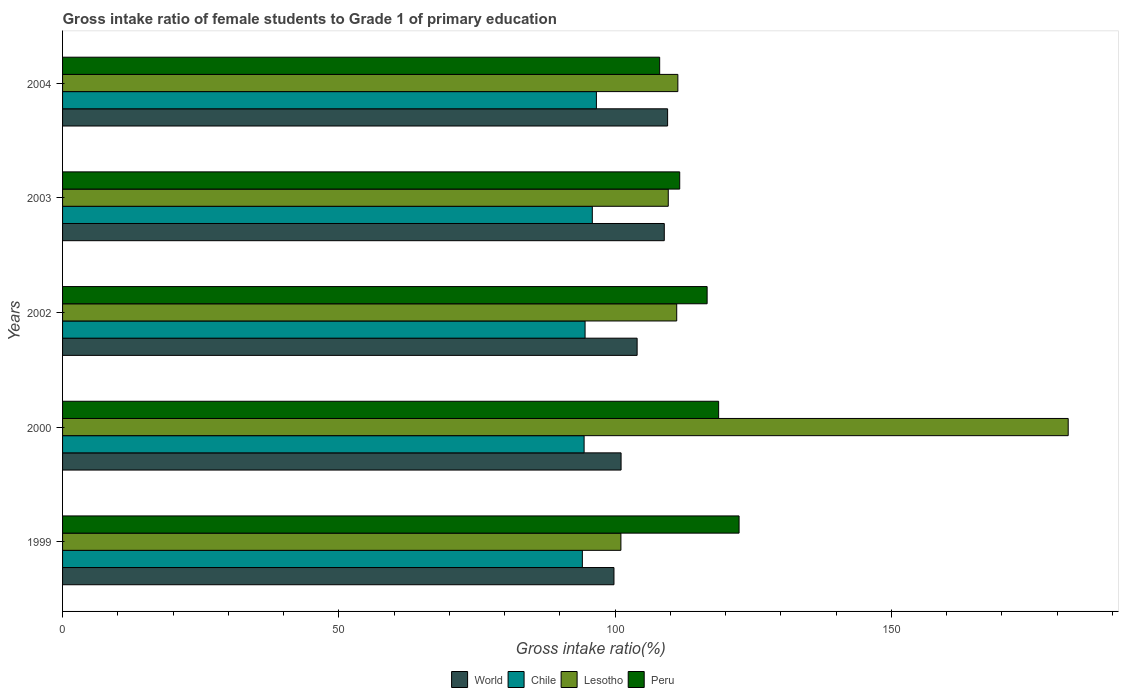How many different coloured bars are there?
Your answer should be very brief. 4. What is the label of the 3rd group of bars from the top?
Your response must be concise. 2002. In how many cases, is the number of bars for a given year not equal to the number of legend labels?
Keep it short and to the point. 0. What is the gross intake ratio in Peru in 2004?
Your response must be concise. 108.07. Across all years, what is the maximum gross intake ratio in Peru?
Provide a succinct answer. 122.45. Across all years, what is the minimum gross intake ratio in World?
Ensure brevity in your answer.  99.8. In which year was the gross intake ratio in Lesotho minimum?
Give a very brief answer. 1999. What is the total gross intake ratio in Peru in the graph?
Your response must be concise. 577.64. What is the difference between the gross intake ratio in Chile in 1999 and that in 2004?
Provide a short and direct response. -2.54. What is the difference between the gross intake ratio in Lesotho in 2000 and the gross intake ratio in World in 2002?
Give a very brief answer. 78.03. What is the average gross intake ratio in Lesotho per year?
Keep it short and to the point. 123.05. In the year 1999, what is the difference between the gross intake ratio in Chile and gross intake ratio in Peru?
Keep it short and to the point. -28.37. In how many years, is the gross intake ratio in Lesotho greater than 170 %?
Your answer should be very brief. 1. What is the ratio of the gross intake ratio in Peru in 2002 to that in 2004?
Your answer should be compact. 1.08. Is the gross intake ratio in Lesotho in 2000 less than that in 2004?
Offer a terse response. No. Is the difference between the gross intake ratio in Chile in 2002 and 2004 greater than the difference between the gross intake ratio in Peru in 2002 and 2004?
Offer a very short reply. No. What is the difference between the highest and the second highest gross intake ratio in World?
Your response must be concise. 0.6. What is the difference between the highest and the lowest gross intake ratio in Lesotho?
Your answer should be very brief. 80.96. Is the sum of the gross intake ratio in World in 2002 and 2004 greater than the maximum gross intake ratio in Peru across all years?
Ensure brevity in your answer.  Yes. What does the 3rd bar from the bottom in 2000 represents?
Your response must be concise. Lesotho. Is it the case that in every year, the sum of the gross intake ratio in Peru and gross intake ratio in World is greater than the gross intake ratio in Chile?
Provide a succinct answer. Yes. How many bars are there?
Your response must be concise. 20. Are all the bars in the graph horizontal?
Provide a succinct answer. Yes. How many years are there in the graph?
Provide a succinct answer. 5. What is the difference between two consecutive major ticks on the X-axis?
Your answer should be compact. 50. Does the graph contain any zero values?
Make the answer very short. No. Does the graph contain grids?
Ensure brevity in your answer.  No. Where does the legend appear in the graph?
Offer a terse response. Bottom center. How many legend labels are there?
Keep it short and to the point. 4. How are the legend labels stacked?
Offer a terse response. Horizontal. What is the title of the graph?
Ensure brevity in your answer.  Gross intake ratio of female students to Grade 1 of primary education. Does "Guam" appear as one of the legend labels in the graph?
Make the answer very short. No. What is the label or title of the X-axis?
Make the answer very short. Gross intake ratio(%). What is the label or title of the Y-axis?
Provide a short and direct response. Years. What is the Gross intake ratio(%) of World in 1999?
Provide a short and direct response. 99.8. What is the Gross intake ratio(%) of Chile in 1999?
Ensure brevity in your answer.  94.08. What is the Gross intake ratio(%) of Lesotho in 1999?
Give a very brief answer. 101.06. What is the Gross intake ratio(%) in Peru in 1999?
Your response must be concise. 122.45. What is the Gross intake ratio(%) in World in 2000?
Provide a short and direct response. 101.09. What is the Gross intake ratio(%) of Chile in 2000?
Provide a succinct answer. 94.4. What is the Gross intake ratio(%) of Lesotho in 2000?
Provide a succinct answer. 182.02. What is the Gross intake ratio(%) in Peru in 2000?
Your answer should be very brief. 118.75. What is the Gross intake ratio(%) in World in 2002?
Ensure brevity in your answer.  103.99. What is the Gross intake ratio(%) of Chile in 2002?
Your answer should be compact. 94.58. What is the Gross intake ratio(%) of Lesotho in 2002?
Your answer should be compact. 111.16. What is the Gross intake ratio(%) of Peru in 2002?
Provide a succinct answer. 116.66. What is the Gross intake ratio(%) of World in 2003?
Provide a succinct answer. 108.91. What is the Gross intake ratio(%) in Chile in 2003?
Provide a short and direct response. 95.88. What is the Gross intake ratio(%) in Lesotho in 2003?
Offer a terse response. 109.63. What is the Gross intake ratio(%) in Peru in 2003?
Your answer should be very brief. 111.7. What is the Gross intake ratio(%) in World in 2004?
Make the answer very short. 109.51. What is the Gross intake ratio(%) of Chile in 2004?
Provide a succinct answer. 96.62. What is the Gross intake ratio(%) in Lesotho in 2004?
Your answer should be compact. 111.37. What is the Gross intake ratio(%) in Peru in 2004?
Your answer should be very brief. 108.07. Across all years, what is the maximum Gross intake ratio(%) in World?
Offer a very short reply. 109.51. Across all years, what is the maximum Gross intake ratio(%) of Chile?
Make the answer very short. 96.62. Across all years, what is the maximum Gross intake ratio(%) in Lesotho?
Give a very brief answer. 182.02. Across all years, what is the maximum Gross intake ratio(%) of Peru?
Provide a short and direct response. 122.45. Across all years, what is the minimum Gross intake ratio(%) in World?
Your response must be concise. 99.8. Across all years, what is the minimum Gross intake ratio(%) in Chile?
Provide a succinct answer. 94.08. Across all years, what is the minimum Gross intake ratio(%) of Lesotho?
Offer a very short reply. 101.06. Across all years, what is the minimum Gross intake ratio(%) of Peru?
Your response must be concise. 108.07. What is the total Gross intake ratio(%) in World in the graph?
Provide a succinct answer. 523.31. What is the total Gross intake ratio(%) of Chile in the graph?
Provide a succinct answer. 475.56. What is the total Gross intake ratio(%) of Lesotho in the graph?
Provide a short and direct response. 615.24. What is the total Gross intake ratio(%) in Peru in the graph?
Offer a very short reply. 577.64. What is the difference between the Gross intake ratio(%) of World in 1999 and that in 2000?
Ensure brevity in your answer.  -1.29. What is the difference between the Gross intake ratio(%) in Chile in 1999 and that in 2000?
Provide a succinct answer. -0.32. What is the difference between the Gross intake ratio(%) in Lesotho in 1999 and that in 2000?
Make the answer very short. -80.96. What is the difference between the Gross intake ratio(%) of Peru in 1999 and that in 2000?
Give a very brief answer. 3.7. What is the difference between the Gross intake ratio(%) in World in 1999 and that in 2002?
Your response must be concise. -4.19. What is the difference between the Gross intake ratio(%) in Chile in 1999 and that in 2002?
Make the answer very short. -0.49. What is the difference between the Gross intake ratio(%) in Lesotho in 1999 and that in 2002?
Keep it short and to the point. -10.1. What is the difference between the Gross intake ratio(%) of Peru in 1999 and that in 2002?
Offer a terse response. 5.78. What is the difference between the Gross intake ratio(%) of World in 1999 and that in 2003?
Provide a short and direct response. -9.11. What is the difference between the Gross intake ratio(%) in Chile in 1999 and that in 2003?
Your answer should be compact. -1.8. What is the difference between the Gross intake ratio(%) of Lesotho in 1999 and that in 2003?
Your answer should be very brief. -8.57. What is the difference between the Gross intake ratio(%) of Peru in 1999 and that in 2003?
Ensure brevity in your answer.  10.74. What is the difference between the Gross intake ratio(%) in World in 1999 and that in 2004?
Provide a succinct answer. -9.71. What is the difference between the Gross intake ratio(%) in Chile in 1999 and that in 2004?
Your answer should be compact. -2.54. What is the difference between the Gross intake ratio(%) of Lesotho in 1999 and that in 2004?
Keep it short and to the point. -10.31. What is the difference between the Gross intake ratio(%) in Peru in 1999 and that in 2004?
Ensure brevity in your answer.  14.37. What is the difference between the Gross intake ratio(%) of World in 2000 and that in 2002?
Your answer should be compact. -2.9. What is the difference between the Gross intake ratio(%) of Chile in 2000 and that in 2002?
Your answer should be very brief. -0.18. What is the difference between the Gross intake ratio(%) in Lesotho in 2000 and that in 2002?
Provide a short and direct response. 70.86. What is the difference between the Gross intake ratio(%) of Peru in 2000 and that in 2002?
Offer a terse response. 2.08. What is the difference between the Gross intake ratio(%) in World in 2000 and that in 2003?
Give a very brief answer. -7.82. What is the difference between the Gross intake ratio(%) of Chile in 2000 and that in 2003?
Provide a short and direct response. -1.49. What is the difference between the Gross intake ratio(%) of Lesotho in 2000 and that in 2003?
Provide a short and direct response. 72.39. What is the difference between the Gross intake ratio(%) in Peru in 2000 and that in 2003?
Ensure brevity in your answer.  7.04. What is the difference between the Gross intake ratio(%) of World in 2000 and that in 2004?
Keep it short and to the point. -8.42. What is the difference between the Gross intake ratio(%) of Chile in 2000 and that in 2004?
Provide a succinct answer. -2.23. What is the difference between the Gross intake ratio(%) of Lesotho in 2000 and that in 2004?
Provide a short and direct response. 70.65. What is the difference between the Gross intake ratio(%) of Peru in 2000 and that in 2004?
Your response must be concise. 10.67. What is the difference between the Gross intake ratio(%) of World in 2002 and that in 2003?
Offer a very short reply. -4.92. What is the difference between the Gross intake ratio(%) of Chile in 2002 and that in 2003?
Your answer should be very brief. -1.31. What is the difference between the Gross intake ratio(%) in Lesotho in 2002 and that in 2003?
Provide a short and direct response. 1.53. What is the difference between the Gross intake ratio(%) in Peru in 2002 and that in 2003?
Offer a terse response. 4.96. What is the difference between the Gross intake ratio(%) of World in 2002 and that in 2004?
Offer a very short reply. -5.52. What is the difference between the Gross intake ratio(%) in Chile in 2002 and that in 2004?
Your answer should be very brief. -2.05. What is the difference between the Gross intake ratio(%) in Lesotho in 2002 and that in 2004?
Your response must be concise. -0.21. What is the difference between the Gross intake ratio(%) in Peru in 2002 and that in 2004?
Provide a succinct answer. 8.59. What is the difference between the Gross intake ratio(%) of World in 2003 and that in 2004?
Make the answer very short. -0.6. What is the difference between the Gross intake ratio(%) in Chile in 2003 and that in 2004?
Keep it short and to the point. -0.74. What is the difference between the Gross intake ratio(%) of Lesotho in 2003 and that in 2004?
Your answer should be compact. -1.74. What is the difference between the Gross intake ratio(%) in Peru in 2003 and that in 2004?
Offer a terse response. 3.63. What is the difference between the Gross intake ratio(%) in World in 1999 and the Gross intake ratio(%) in Chile in 2000?
Your response must be concise. 5.41. What is the difference between the Gross intake ratio(%) in World in 1999 and the Gross intake ratio(%) in Lesotho in 2000?
Your answer should be very brief. -82.22. What is the difference between the Gross intake ratio(%) in World in 1999 and the Gross intake ratio(%) in Peru in 2000?
Offer a very short reply. -18.94. What is the difference between the Gross intake ratio(%) in Chile in 1999 and the Gross intake ratio(%) in Lesotho in 2000?
Make the answer very short. -87.94. What is the difference between the Gross intake ratio(%) of Chile in 1999 and the Gross intake ratio(%) of Peru in 2000?
Make the answer very short. -24.67. What is the difference between the Gross intake ratio(%) in Lesotho in 1999 and the Gross intake ratio(%) in Peru in 2000?
Provide a short and direct response. -17.69. What is the difference between the Gross intake ratio(%) of World in 1999 and the Gross intake ratio(%) of Chile in 2002?
Offer a very short reply. 5.23. What is the difference between the Gross intake ratio(%) of World in 1999 and the Gross intake ratio(%) of Lesotho in 2002?
Make the answer very short. -11.36. What is the difference between the Gross intake ratio(%) in World in 1999 and the Gross intake ratio(%) in Peru in 2002?
Your answer should be compact. -16.86. What is the difference between the Gross intake ratio(%) of Chile in 1999 and the Gross intake ratio(%) of Lesotho in 2002?
Keep it short and to the point. -17.08. What is the difference between the Gross intake ratio(%) of Chile in 1999 and the Gross intake ratio(%) of Peru in 2002?
Offer a very short reply. -22.58. What is the difference between the Gross intake ratio(%) in Lesotho in 1999 and the Gross intake ratio(%) in Peru in 2002?
Provide a succinct answer. -15.61. What is the difference between the Gross intake ratio(%) in World in 1999 and the Gross intake ratio(%) in Chile in 2003?
Offer a very short reply. 3.92. What is the difference between the Gross intake ratio(%) of World in 1999 and the Gross intake ratio(%) of Lesotho in 2003?
Offer a terse response. -9.83. What is the difference between the Gross intake ratio(%) in World in 1999 and the Gross intake ratio(%) in Peru in 2003?
Offer a terse response. -11.9. What is the difference between the Gross intake ratio(%) in Chile in 1999 and the Gross intake ratio(%) in Lesotho in 2003?
Keep it short and to the point. -15.55. What is the difference between the Gross intake ratio(%) of Chile in 1999 and the Gross intake ratio(%) of Peru in 2003?
Your response must be concise. -17.62. What is the difference between the Gross intake ratio(%) of Lesotho in 1999 and the Gross intake ratio(%) of Peru in 2003?
Your response must be concise. -10.65. What is the difference between the Gross intake ratio(%) of World in 1999 and the Gross intake ratio(%) of Chile in 2004?
Provide a short and direct response. 3.18. What is the difference between the Gross intake ratio(%) of World in 1999 and the Gross intake ratio(%) of Lesotho in 2004?
Make the answer very short. -11.56. What is the difference between the Gross intake ratio(%) of World in 1999 and the Gross intake ratio(%) of Peru in 2004?
Your answer should be very brief. -8.27. What is the difference between the Gross intake ratio(%) in Chile in 1999 and the Gross intake ratio(%) in Lesotho in 2004?
Provide a succinct answer. -17.29. What is the difference between the Gross intake ratio(%) in Chile in 1999 and the Gross intake ratio(%) in Peru in 2004?
Your answer should be very brief. -13.99. What is the difference between the Gross intake ratio(%) of Lesotho in 1999 and the Gross intake ratio(%) of Peru in 2004?
Give a very brief answer. -7.02. What is the difference between the Gross intake ratio(%) of World in 2000 and the Gross intake ratio(%) of Chile in 2002?
Your answer should be very brief. 6.52. What is the difference between the Gross intake ratio(%) of World in 2000 and the Gross intake ratio(%) of Lesotho in 2002?
Keep it short and to the point. -10.07. What is the difference between the Gross intake ratio(%) of World in 2000 and the Gross intake ratio(%) of Peru in 2002?
Provide a succinct answer. -15.57. What is the difference between the Gross intake ratio(%) of Chile in 2000 and the Gross intake ratio(%) of Lesotho in 2002?
Make the answer very short. -16.76. What is the difference between the Gross intake ratio(%) of Chile in 2000 and the Gross intake ratio(%) of Peru in 2002?
Your answer should be compact. -22.27. What is the difference between the Gross intake ratio(%) of Lesotho in 2000 and the Gross intake ratio(%) of Peru in 2002?
Offer a very short reply. 65.36. What is the difference between the Gross intake ratio(%) in World in 2000 and the Gross intake ratio(%) in Chile in 2003?
Provide a succinct answer. 5.21. What is the difference between the Gross intake ratio(%) of World in 2000 and the Gross intake ratio(%) of Lesotho in 2003?
Your answer should be compact. -8.54. What is the difference between the Gross intake ratio(%) of World in 2000 and the Gross intake ratio(%) of Peru in 2003?
Your response must be concise. -10.61. What is the difference between the Gross intake ratio(%) of Chile in 2000 and the Gross intake ratio(%) of Lesotho in 2003?
Your answer should be very brief. -15.23. What is the difference between the Gross intake ratio(%) in Chile in 2000 and the Gross intake ratio(%) in Peru in 2003?
Offer a very short reply. -17.31. What is the difference between the Gross intake ratio(%) in Lesotho in 2000 and the Gross intake ratio(%) in Peru in 2003?
Ensure brevity in your answer.  70.32. What is the difference between the Gross intake ratio(%) of World in 2000 and the Gross intake ratio(%) of Chile in 2004?
Offer a terse response. 4.47. What is the difference between the Gross intake ratio(%) in World in 2000 and the Gross intake ratio(%) in Lesotho in 2004?
Provide a short and direct response. -10.28. What is the difference between the Gross intake ratio(%) of World in 2000 and the Gross intake ratio(%) of Peru in 2004?
Give a very brief answer. -6.98. What is the difference between the Gross intake ratio(%) of Chile in 2000 and the Gross intake ratio(%) of Lesotho in 2004?
Ensure brevity in your answer.  -16.97. What is the difference between the Gross intake ratio(%) in Chile in 2000 and the Gross intake ratio(%) in Peru in 2004?
Ensure brevity in your answer.  -13.68. What is the difference between the Gross intake ratio(%) in Lesotho in 2000 and the Gross intake ratio(%) in Peru in 2004?
Your answer should be compact. 73.95. What is the difference between the Gross intake ratio(%) in World in 2002 and the Gross intake ratio(%) in Chile in 2003?
Your answer should be compact. 8.11. What is the difference between the Gross intake ratio(%) in World in 2002 and the Gross intake ratio(%) in Lesotho in 2003?
Offer a very short reply. -5.64. What is the difference between the Gross intake ratio(%) of World in 2002 and the Gross intake ratio(%) of Peru in 2003?
Ensure brevity in your answer.  -7.71. What is the difference between the Gross intake ratio(%) in Chile in 2002 and the Gross intake ratio(%) in Lesotho in 2003?
Provide a succinct answer. -15.06. What is the difference between the Gross intake ratio(%) in Chile in 2002 and the Gross intake ratio(%) in Peru in 2003?
Offer a terse response. -17.13. What is the difference between the Gross intake ratio(%) in Lesotho in 2002 and the Gross intake ratio(%) in Peru in 2003?
Make the answer very short. -0.54. What is the difference between the Gross intake ratio(%) of World in 2002 and the Gross intake ratio(%) of Chile in 2004?
Your answer should be compact. 7.37. What is the difference between the Gross intake ratio(%) of World in 2002 and the Gross intake ratio(%) of Lesotho in 2004?
Keep it short and to the point. -7.37. What is the difference between the Gross intake ratio(%) in World in 2002 and the Gross intake ratio(%) in Peru in 2004?
Keep it short and to the point. -4.08. What is the difference between the Gross intake ratio(%) of Chile in 2002 and the Gross intake ratio(%) of Lesotho in 2004?
Keep it short and to the point. -16.79. What is the difference between the Gross intake ratio(%) in Chile in 2002 and the Gross intake ratio(%) in Peru in 2004?
Provide a short and direct response. -13.5. What is the difference between the Gross intake ratio(%) in Lesotho in 2002 and the Gross intake ratio(%) in Peru in 2004?
Your answer should be very brief. 3.09. What is the difference between the Gross intake ratio(%) in World in 2003 and the Gross intake ratio(%) in Chile in 2004?
Keep it short and to the point. 12.29. What is the difference between the Gross intake ratio(%) in World in 2003 and the Gross intake ratio(%) in Lesotho in 2004?
Keep it short and to the point. -2.46. What is the difference between the Gross intake ratio(%) of World in 2003 and the Gross intake ratio(%) of Peru in 2004?
Ensure brevity in your answer.  0.84. What is the difference between the Gross intake ratio(%) of Chile in 2003 and the Gross intake ratio(%) of Lesotho in 2004?
Your answer should be compact. -15.48. What is the difference between the Gross intake ratio(%) of Chile in 2003 and the Gross intake ratio(%) of Peru in 2004?
Give a very brief answer. -12.19. What is the difference between the Gross intake ratio(%) in Lesotho in 2003 and the Gross intake ratio(%) in Peru in 2004?
Offer a terse response. 1.56. What is the average Gross intake ratio(%) of World per year?
Your answer should be compact. 104.66. What is the average Gross intake ratio(%) of Chile per year?
Provide a succinct answer. 95.11. What is the average Gross intake ratio(%) of Lesotho per year?
Your answer should be compact. 123.05. What is the average Gross intake ratio(%) of Peru per year?
Provide a succinct answer. 115.53. In the year 1999, what is the difference between the Gross intake ratio(%) of World and Gross intake ratio(%) of Chile?
Provide a succinct answer. 5.72. In the year 1999, what is the difference between the Gross intake ratio(%) of World and Gross intake ratio(%) of Lesotho?
Offer a terse response. -1.26. In the year 1999, what is the difference between the Gross intake ratio(%) in World and Gross intake ratio(%) in Peru?
Give a very brief answer. -22.64. In the year 1999, what is the difference between the Gross intake ratio(%) in Chile and Gross intake ratio(%) in Lesotho?
Your answer should be compact. -6.98. In the year 1999, what is the difference between the Gross intake ratio(%) in Chile and Gross intake ratio(%) in Peru?
Provide a succinct answer. -28.37. In the year 1999, what is the difference between the Gross intake ratio(%) of Lesotho and Gross intake ratio(%) of Peru?
Offer a terse response. -21.39. In the year 2000, what is the difference between the Gross intake ratio(%) in World and Gross intake ratio(%) in Chile?
Your answer should be very brief. 6.69. In the year 2000, what is the difference between the Gross intake ratio(%) of World and Gross intake ratio(%) of Lesotho?
Make the answer very short. -80.93. In the year 2000, what is the difference between the Gross intake ratio(%) of World and Gross intake ratio(%) of Peru?
Keep it short and to the point. -17.66. In the year 2000, what is the difference between the Gross intake ratio(%) of Chile and Gross intake ratio(%) of Lesotho?
Ensure brevity in your answer.  -87.62. In the year 2000, what is the difference between the Gross intake ratio(%) in Chile and Gross intake ratio(%) in Peru?
Provide a short and direct response. -24.35. In the year 2000, what is the difference between the Gross intake ratio(%) of Lesotho and Gross intake ratio(%) of Peru?
Provide a succinct answer. 63.27. In the year 2002, what is the difference between the Gross intake ratio(%) in World and Gross intake ratio(%) in Chile?
Provide a succinct answer. 9.42. In the year 2002, what is the difference between the Gross intake ratio(%) in World and Gross intake ratio(%) in Lesotho?
Offer a very short reply. -7.17. In the year 2002, what is the difference between the Gross intake ratio(%) in World and Gross intake ratio(%) in Peru?
Make the answer very short. -12.67. In the year 2002, what is the difference between the Gross intake ratio(%) of Chile and Gross intake ratio(%) of Lesotho?
Keep it short and to the point. -16.59. In the year 2002, what is the difference between the Gross intake ratio(%) of Chile and Gross intake ratio(%) of Peru?
Give a very brief answer. -22.09. In the year 2002, what is the difference between the Gross intake ratio(%) of Lesotho and Gross intake ratio(%) of Peru?
Provide a short and direct response. -5.5. In the year 2003, what is the difference between the Gross intake ratio(%) of World and Gross intake ratio(%) of Chile?
Keep it short and to the point. 13.03. In the year 2003, what is the difference between the Gross intake ratio(%) of World and Gross intake ratio(%) of Lesotho?
Your answer should be compact. -0.72. In the year 2003, what is the difference between the Gross intake ratio(%) in World and Gross intake ratio(%) in Peru?
Give a very brief answer. -2.79. In the year 2003, what is the difference between the Gross intake ratio(%) in Chile and Gross intake ratio(%) in Lesotho?
Ensure brevity in your answer.  -13.75. In the year 2003, what is the difference between the Gross intake ratio(%) in Chile and Gross intake ratio(%) in Peru?
Offer a terse response. -15.82. In the year 2003, what is the difference between the Gross intake ratio(%) in Lesotho and Gross intake ratio(%) in Peru?
Keep it short and to the point. -2.07. In the year 2004, what is the difference between the Gross intake ratio(%) in World and Gross intake ratio(%) in Chile?
Your answer should be compact. 12.89. In the year 2004, what is the difference between the Gross intake ratio(%) of World and Gross intake ratio(%) of Lesotho?
Offer a terse response. -1.86. In the year 2004, what is the difference between the Gross intake ratio(%) in World and Gross intake ratio(%) in Peru?
Offer a very short reply. 1.44. In the year 2004, what is the difference between the Gross intake ratio(%) in Chile and Gross intake ratio(%) in Lesotho?
Offer a very short reply. -14.74. In the year 2004, what is the difference between the Gross intake ratio(%) in Chile and Gross intake ratio(%) in Peru?
Your answer should be very brief. -11.45. In the year 2004, what is the difference between the Gross intake ratio(%) of Lesotho and Gross intake ratio(%) of Peru?
Provide a succinct answer. 3.29. What is the ratio of the Gross intake ratio(%) of World in 1999 to that in 2000?
Give a very brief answer. 0.99. What is the ratio of the Gross intake ratio(%) of Chile in 1999 to that in 2000?
Provide a short and direct response. 1. What is the ratio of the Gross intake ratio(%) in Lesotho in 1999 to that in 2000?
Your answer should be very brief. 0.56. What is the ratio of the Gross intake ratio(%) in Peru in 1999 to that in 2000?
Ensure brevity in your answer.  1.03. What is the ratio of the Gross intake ratio(%) of World in 1999 to that in 2002?
Ensure brevity in your answer.  0.96. What is the ratio of the Gross intake ratio(%) in Chile in 1999 to that in 2002?
Offer a terse response. 0.99. What is the ratio of the Gross intake ratio(%) in Peru in 1999 to that in 2002?
Give a very brief answer. 1.05. What is the ratio of the Gross intake ratio(%) of World in 1999 to that in 2003?
Offer a very short reply. 0.92. What is the ratio of the Gross intake ratio(%) of Chile in 1999 to that in 2003?
Make the answer very short. 0.98. What is the ratio of the Gross intake ratio(%) of Lesotho in 1999 to that in 2003?
Give a very brief answer. 0.92. What is the ratio of the Gross intake ratio(%) in Peru in 1999 to that in 2003?
Your answer should be very brief. 1.1. What is the ratio of the Gross intake ratio(%) of World in 1999 to that in 2004?
Offer a terse response. 0.91. What is the ratio of the Gross intake ratio(%) in Chile in 1999 to that in 2004?
Provide a succinct answer. 0.97. What is the ratio of the Gross intake ratio(%) in Lesotho in 1999 to that in 2004?
Your response must be concise. 0.91. What is the ratio of the Gross intake ratio(%) in Peru in 1999 to that in 2004?
Your response must be concise. 1.13. What is the ratio of the Gross intake ratio(%) of World in 2000 to that in 2002?
Ensure brevity in your answer.  0.97. What is the ratio of the Gross intake ratio(%) of Lesotho in 2000 to that in 2002?
Your response must be concise. 1.64. What is the ratio of the Gross intake ratio(%) of Peru in 2000 to that in 2002?
Give a very brief answer. 1.02. What is the ratio of the Gross intake ratio(%) in World in 2000 to that in 2003?
Give a very brief answer. 0.93. What is the ratio of the Gross intake ratio(%) of Chile in 2000 to that in 2003?
Provide a succinct answer. 0.98. What is the ratio of the Gross intake ratio(%) of Lesotho in 2000 to that in 2003?
Make the answer very short. 1.66. What is the ratio of the Gross intake ratio(%) of Peru in 2000 to that in 2003?
Make the answer very short. 1.06. What is the ratio of the Gross intake ratio(%) in Chile in 2000 to that in 2004?
Give a very brief answer. 0.98. What is the ratio of the Gross intake ratio(%) of Lesotho in 2000 to that in 2004?
Your answer should be compact. 1.63. What is the ratio of the Gross intake ratio(%) of Peru in 2000 to that in 2004?
Provide a short and direct response. 1.1. What is the ratio of the Gross intake ratio(%) in World in 2002 to that in 2003?
Offer a terse response. 0.95. What is the ratio of the Gross intake ratio(%) of Chile in 2002 to that in 2003?
Make the answer very short. 0.99. What is the ratio of the Gross intake ratio(%) of Peru in 2002 to that in 2003?
Ensure brevity in your answer.  1.04. What is the ratio of the Gross intake ratio(%) of World in 2002 to that in 2004?
Your answer should be compact. 0.95. What is the ratio of the Gross intake ratio(%) in Chile in 2002 to that in 2004?
Provide a short and direct response. 0.98. What is the ratio of the Gross intake ratio(%) in Peru in 2002 to that in 2004?
Ensure brevity in your answer.  1.08. What is the ratio of the Gross intake ratio(%) in Lesotho in 2003 to that in 2004?
Offer a very short reply. 0.98. What is the ratio of the Gross intake ratio(%) of Peru in 2003 to that in 2004?
Provide a short and direct response. 1.03. What is the difference between the highest and the second highest Gross intake ratio(%) of World?
Your response must be concise. 0.6. What is the difference between the highest and the second highest Gross intake ratio(%) in Chile?
Your answer should be very brief. 0.74. What is the difference between the highest and the second highest Gross intake ratio(%) in Lesotho?
Keep it short and to the point. 70.65. What is the difference between the highest and the second highest Gross intake ratio(%) in Peru?
Keep it short and to the point. 3.7. What is the difference between the highest and the lowest Gross intake ratio(%) in World?
Keep it short and to the point. 9.71. What is the difference between the highest and the lowest Gross intake ratio(%) of Chile?
Your answer should be very brief. 2.54. What is the difference between the highest and the lowest Gross intake ratio(%) of Lesotho?
Keep it short and to the point. 80.96. What is the difference between the highest and the lowest Gross intake ratio(%) in Peru?
Offer a very short reply. 14.37. 